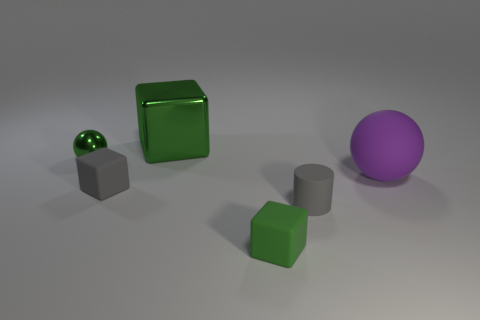Subtract 1 cubes. How many cubes are left? 2 Subtract all matte cubes. How many cubes are left? 1 Add 1 gray cylinders. How many objects exist? 7 Subtract all cylinders. How many objects are left? 5 Subtract all tiny green shiny balls. Subtract all red cubes. How many objects are left? 5 Add 2 green metal spheres. How many green metal spheres are left? 3 Add 3 big purple objects. How many big purple objects exist? 4 Subtract 0 purple cubes. How many objects are left? 6 